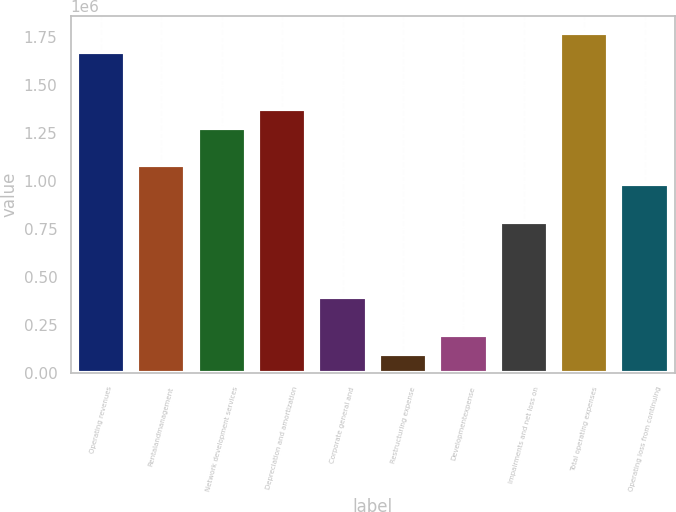<chart> <loc_0><loc_0><loc_500><loc_500><bar_chart><fcel>Operating revenues<fcel>Rentalandmanagement<fcel>Network development services<fcel>Depreciation and amortization<fcel>Corporate general and<fcel>Restructuring expense<fcel>Developmentexpense<fcel>Impairments and net loss on<fcel>Total operating expenses<fcel>Operating loss from continuing<nl><fcel>1.67364e+06<fcel>1.08306e+06<fcel>1.27992e+06<fcel>1.37835e+06<fcel>394041<fcel>98748.8<fcel>197180<fcel>787764<fcel>1.77207e+06<fcel>984626<nl></chart> 